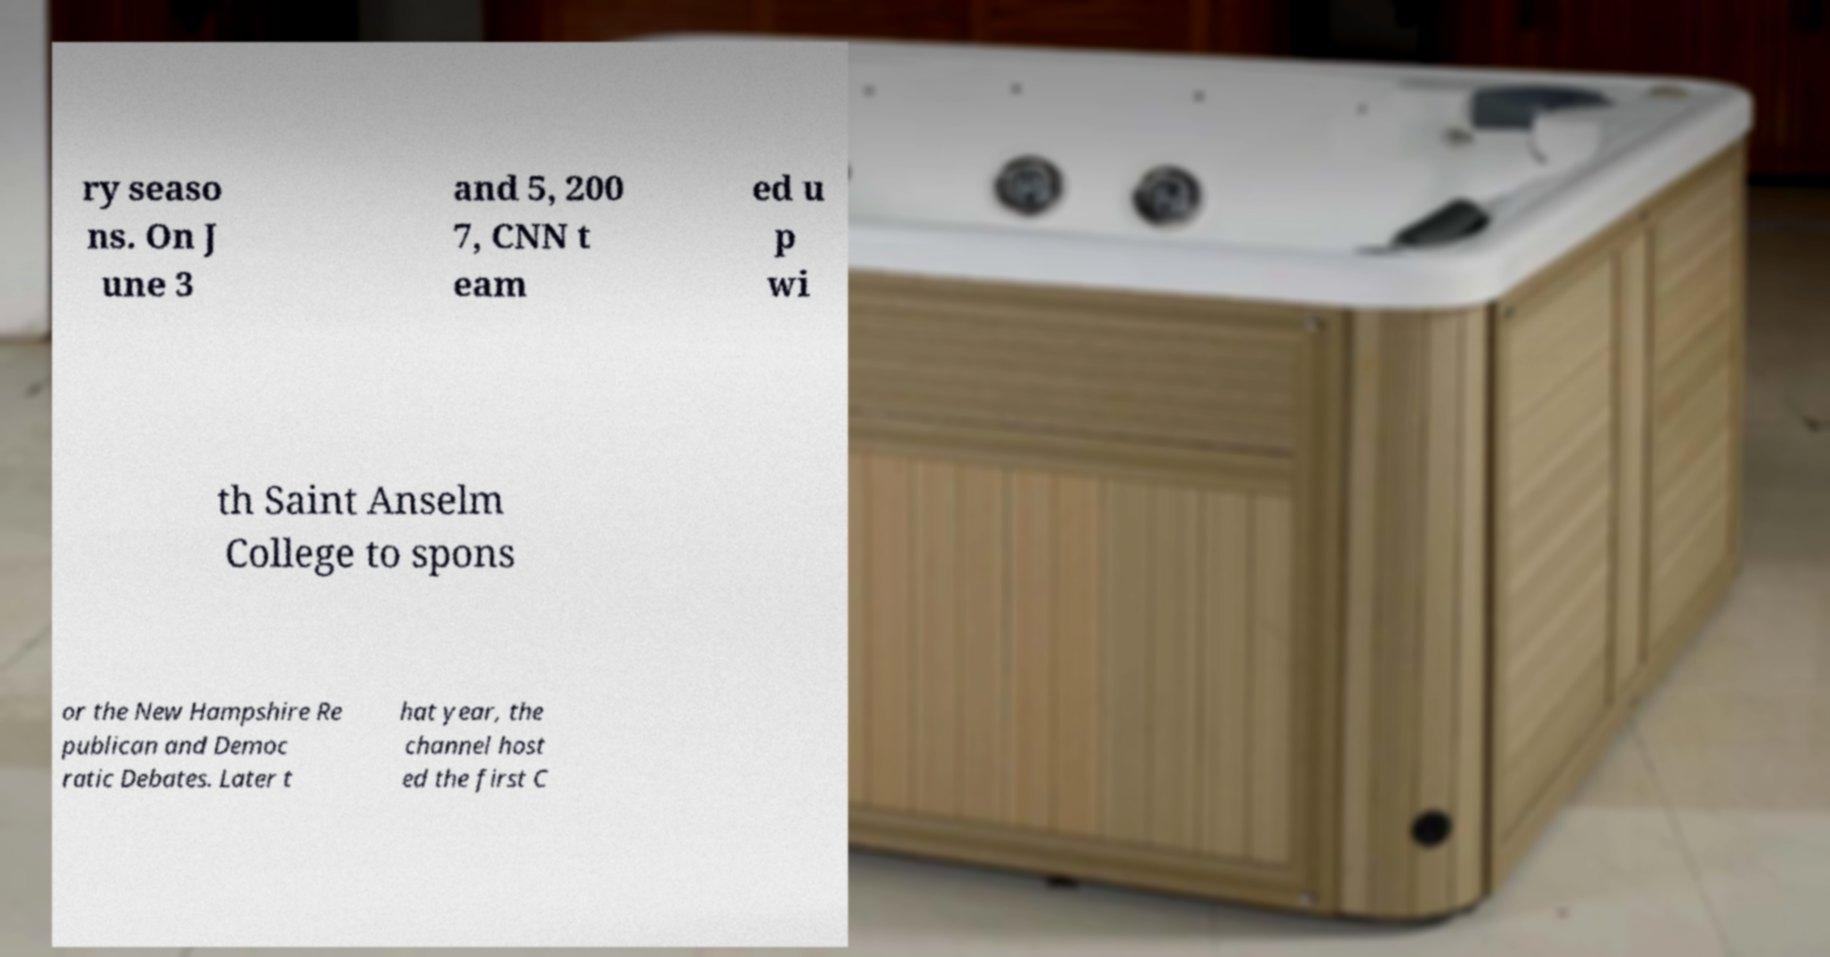I need the written content from this picture converted into text. Can you do that? ry seaso ns. On J une 3 and 5, 200 7, CNN t eam ed u p wi th Saint Anselm College to spons or the New Hampshire Re publican and Democ ratic Debates. Later t hat year, the channel host ed the first C 